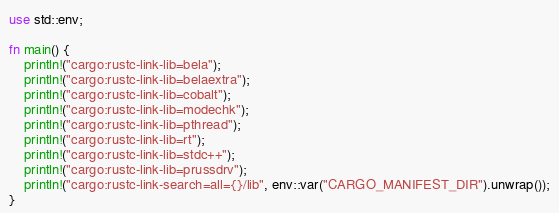Convert code to text. <code><loc_0><loc_0><loc_500><loc_500><_Rust_>use std::env;

fn main() {
    println!("cargo:rustc-link-lib=bela");
    println!("cargo:rustc-link-lib=belaextra");
    println!("cargo:rustc-link-lib=cobalt");
    println!("cargo:rustc-link-lib=modechk");
    println!("cargo:rustc-link-lib=pthread");
    println!("cargo:rustc-link-lib=rt");
    println!("cargo:rustc-link-lib=stdc++");
    println!("cargo:rustc-link-lib=prussdrv");
    println!("cargo:rustc-link-search=all={}/lib", env::var("CARGO_MANIFEST_DIR").unwrap());
}
</code> 